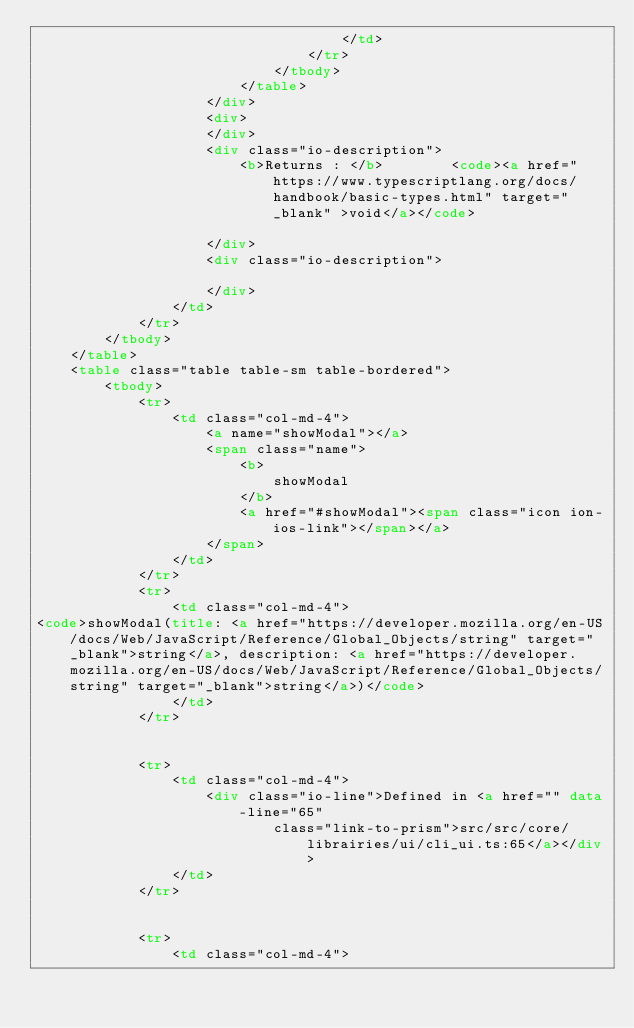Convert code to text. <code><loc_0><loc_0><loc_500><loc_500><_HTML_>                                    </td>
                                </tr>
                            </tbody>
                        </table>
                    </div>
                    <div>
                    </div>
                    <div class="io-description">
                        <b>Returns : </b>        <code><a href="https://www.typescriptlang.org/docs/handbook/basic-types.html" target="_blank" >void</a></code>

                    </div>
                    <div class="io-description">
                        
                    </div>
                </td>
            </tr>
        </tbody>
    </table>
    <table class="table table-sm table-bordered">
        <tbody>
            <tr>
                <td class="col-md-4">
                    <a name="showModal"></a>
                    <span class="name">
                        <b>
                            showModal
                        </b>
                        <a href="#showModal"><span class="icon ion-ios-link"></span></a>
                    </span>
                </td>
            </tr>
            <tr>
                <td class="col-md-4">
<code>showModal(title: <a href="https://developer.mozilla.org/en-US/docs/Web/JavaScript/Reference/Global_Objects/string" target="_blank">string</a>, description: <a href="https://developer.mozilla.org/en-US/docs/Web/JavaScript/Reference/Global_Objects/string" target="_blank">string</a>)</code>
                </td>
            </tr>


            <tr>
                <td class="col-md-4">
                    <div class="io-line">Defined in <a href="" data-line="65"
                            class="link-to-prism">src/src/core/librairies/ui/cli_ui.ts:65</a></div>
                </td>
            </tr>


            <tr>
                <td class="col-md-4"></code> 